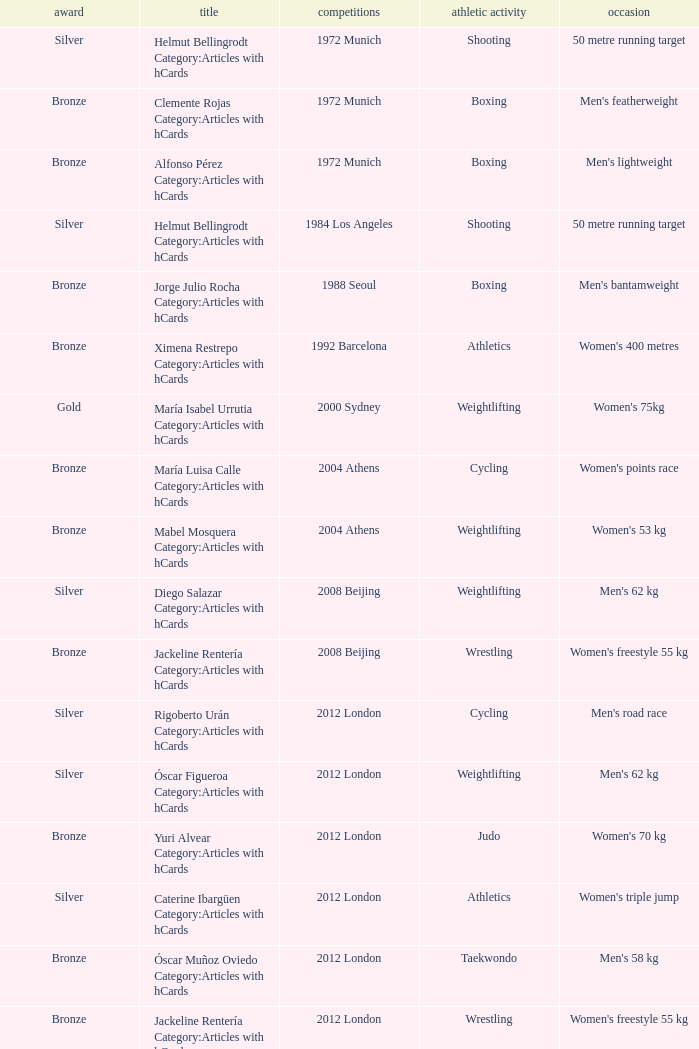Which sport resulted in a gold medal in the 2000 Sydney games? Weightlifting. 